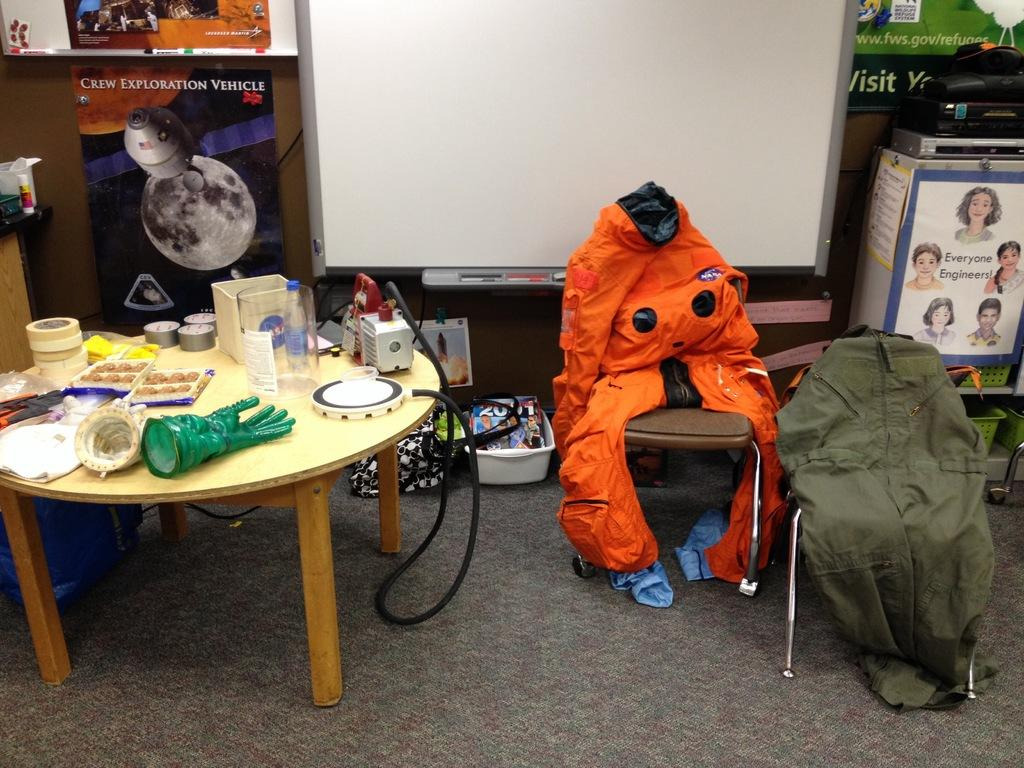What is placed on the chairs in the image? There is a dress on the chairs in the image. On which side of the image is the dress located? The dress is on the right side of the image. What can be found on the left side of the image? There are food items, gloves, and electronic gadgets on the left side of the image. Can you describe the food items in the image? The food items are not specified, but they are located on the left side of the image. What type of accessory is present in the image? There are gloves in the image. How many jellyfish are swimming in the image? There are no jellyfish present in the image. What type of fruit is being eaten by the apple in the image? There is no apple present in the image. 